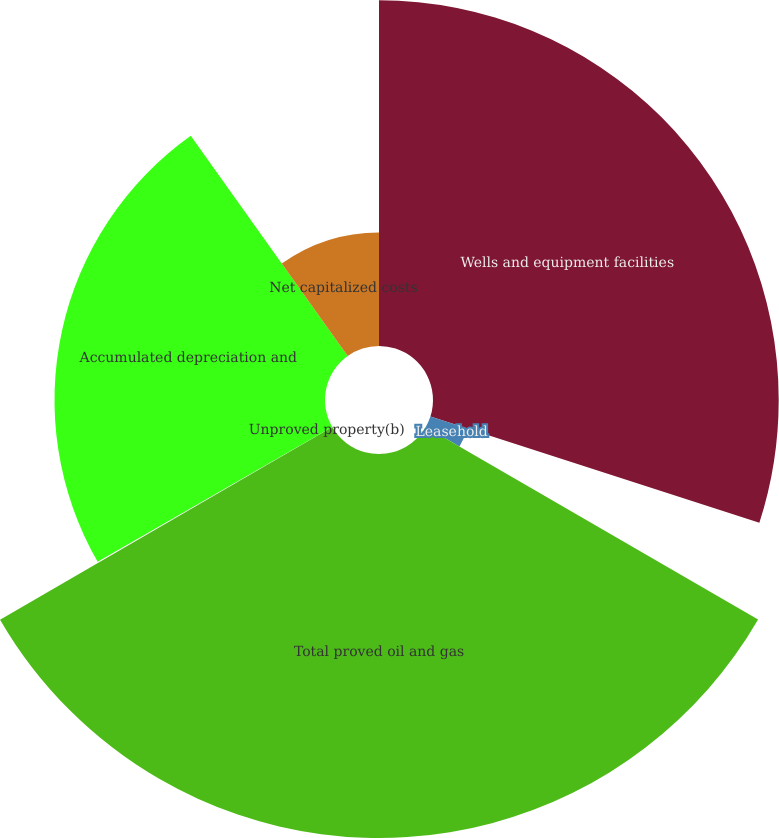Convert chart. <chart><loc_0><loc_0><loc_500><loc_500><pie_chart><fcel>Wells and equipment facilities<fcel>Leasehold<fcel>Total proved oil and gas<fcel>Unproved property(b)<fcel>Accumulated depreciation and<fcel>Net capitalized costs<nl><fcel>29.97%<fcel>3.38%<fcel>33.29%<fcel>0.06%<fcel>23.45%<fcel>9.85%<nl></chart> 